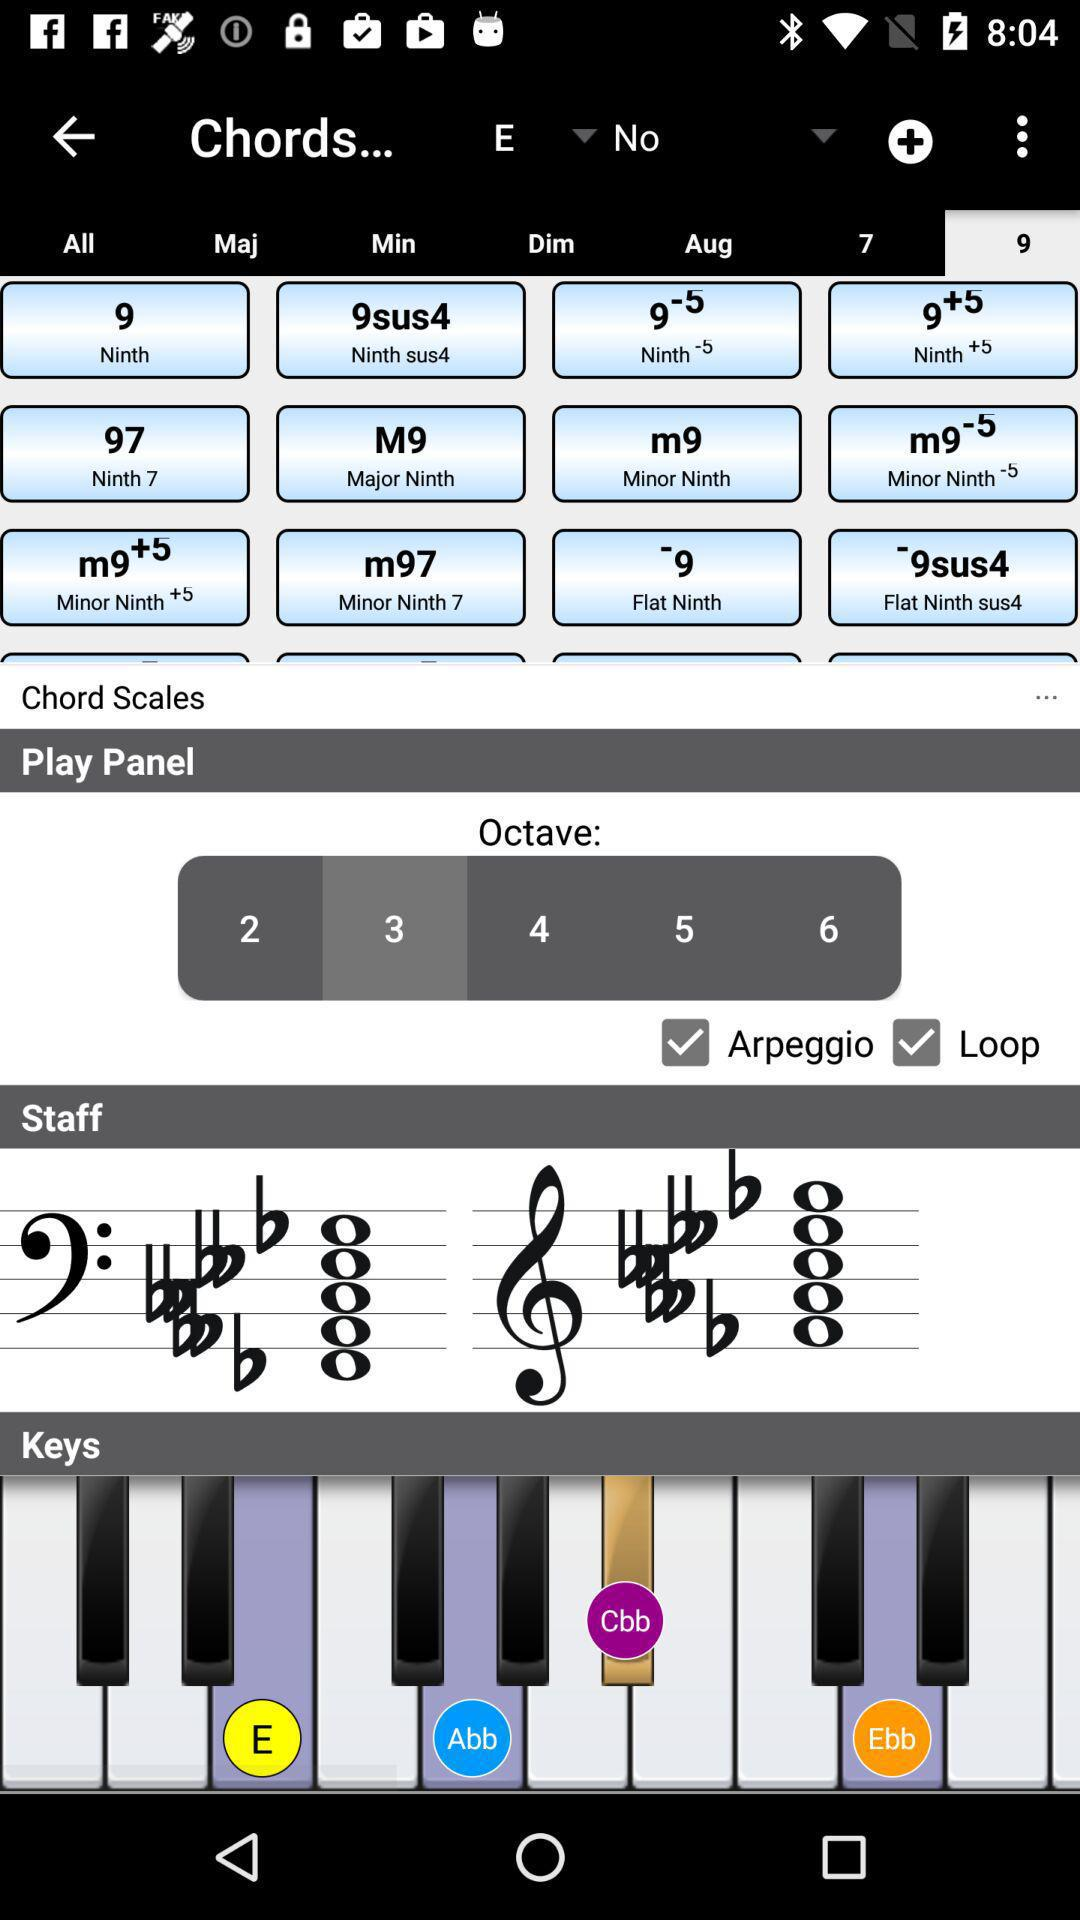Which octave is selected? The selected octave is 3. 